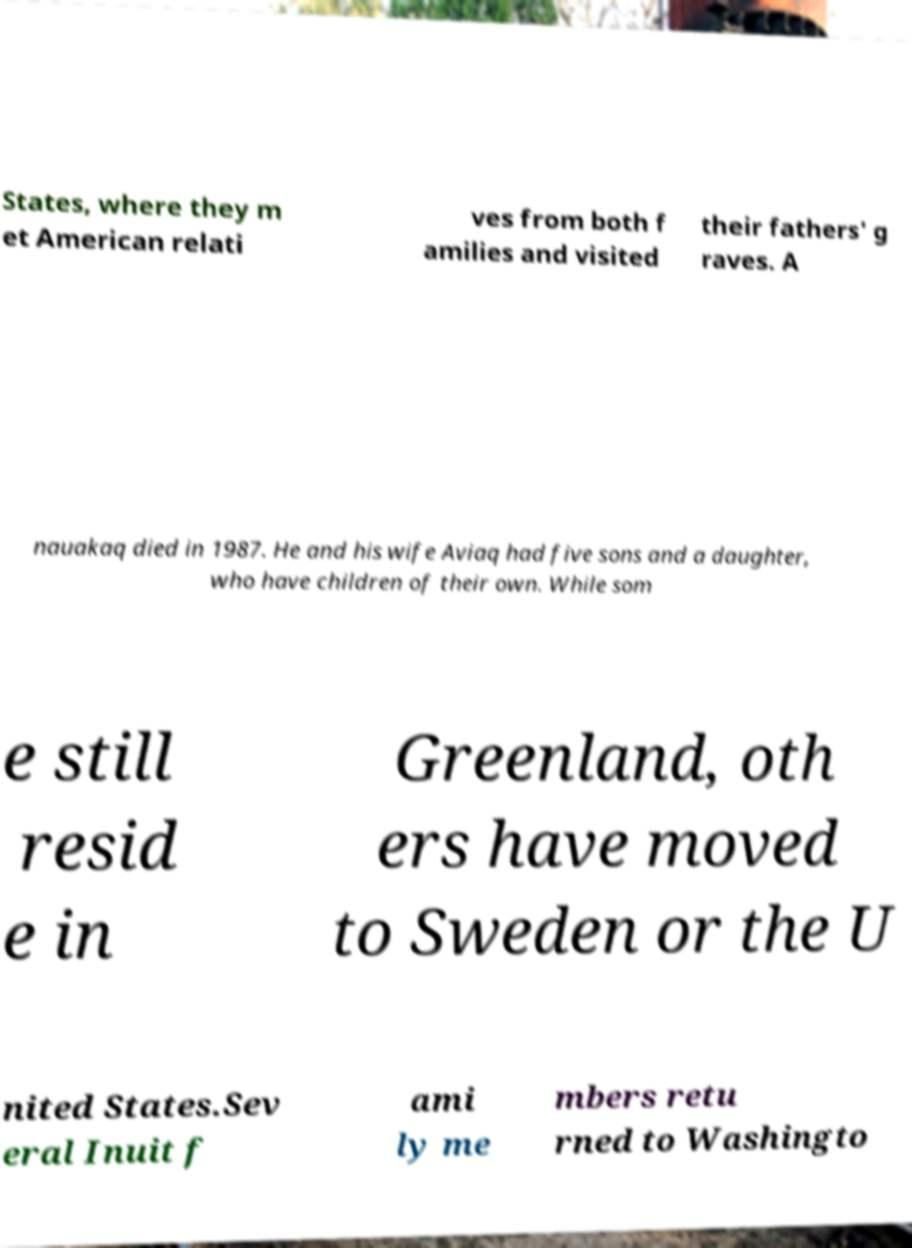I need the written content from this picture converted into text. Can you do that? States, where they m et American relati ves from both f amilies and visited their fathers' g raves. A nauakaq died in 1987. He and his wife Aviaq had five sons and a daughter, who have children of their own. While som e still resid e in Greenland, oth ers have moved to Sweden or the U nited States.Sev eral Inuit f ami ly me mbers retu rned to Washingto 